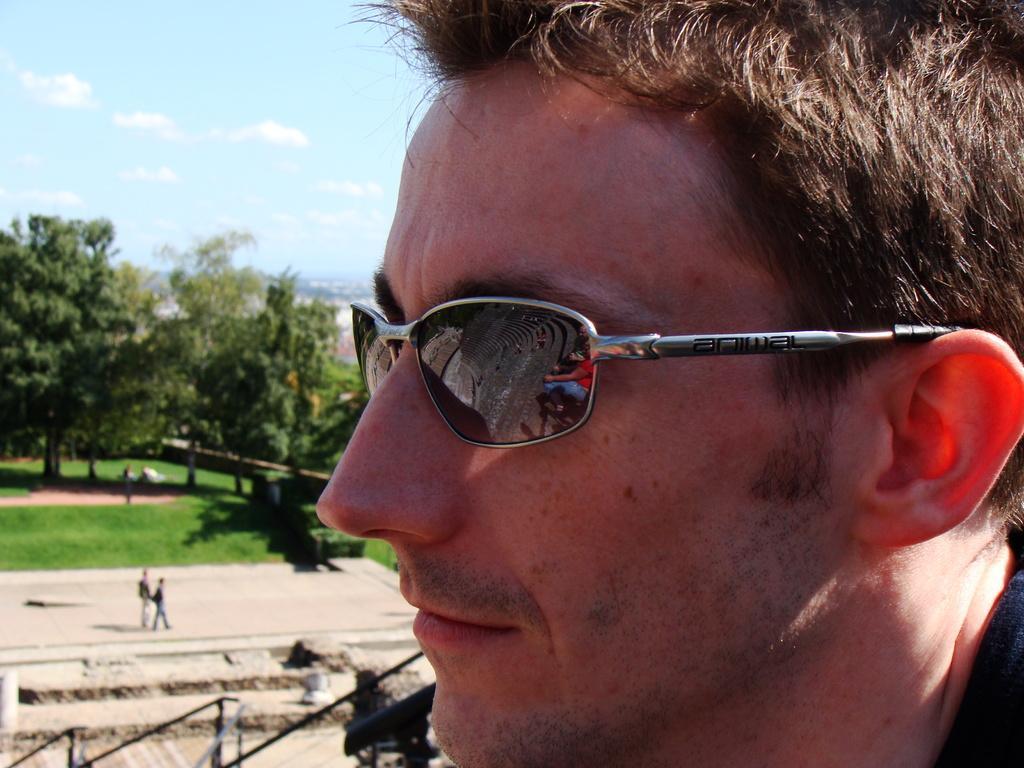In one or two sentences, can you explain what this image depicts? In this picture we can see a man wore goggles, two people on the ground, fence, trees, grass and some objects and in the background we can see the sky with clouds. 